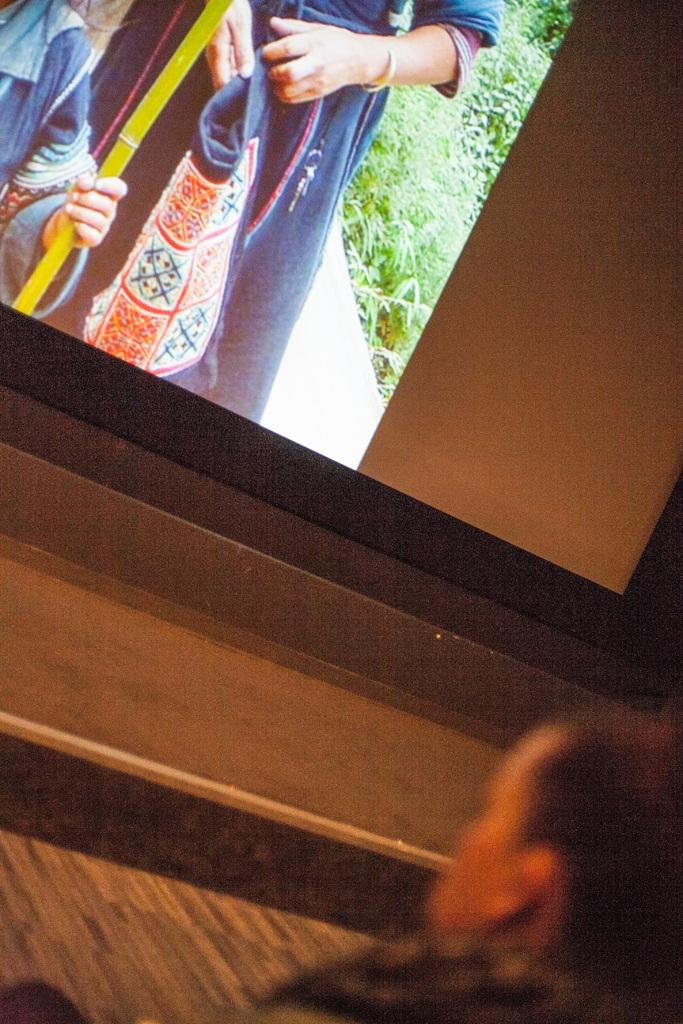What is the main subject of the image? There is a person in the image. What is the person interacting with or looking at in the image? There is a projector screen in the image. What can be seen on the projector screen? There are two people visible on the projector screen. What type of natural environment is present in the image? Grass is present in the image. What type of sofa can be seen in the image? There is no sofa present in the image. What time of day is it in the image, based on the presence of morning light? The time of day is not indicated in the image, as there is no mention of light or time. 